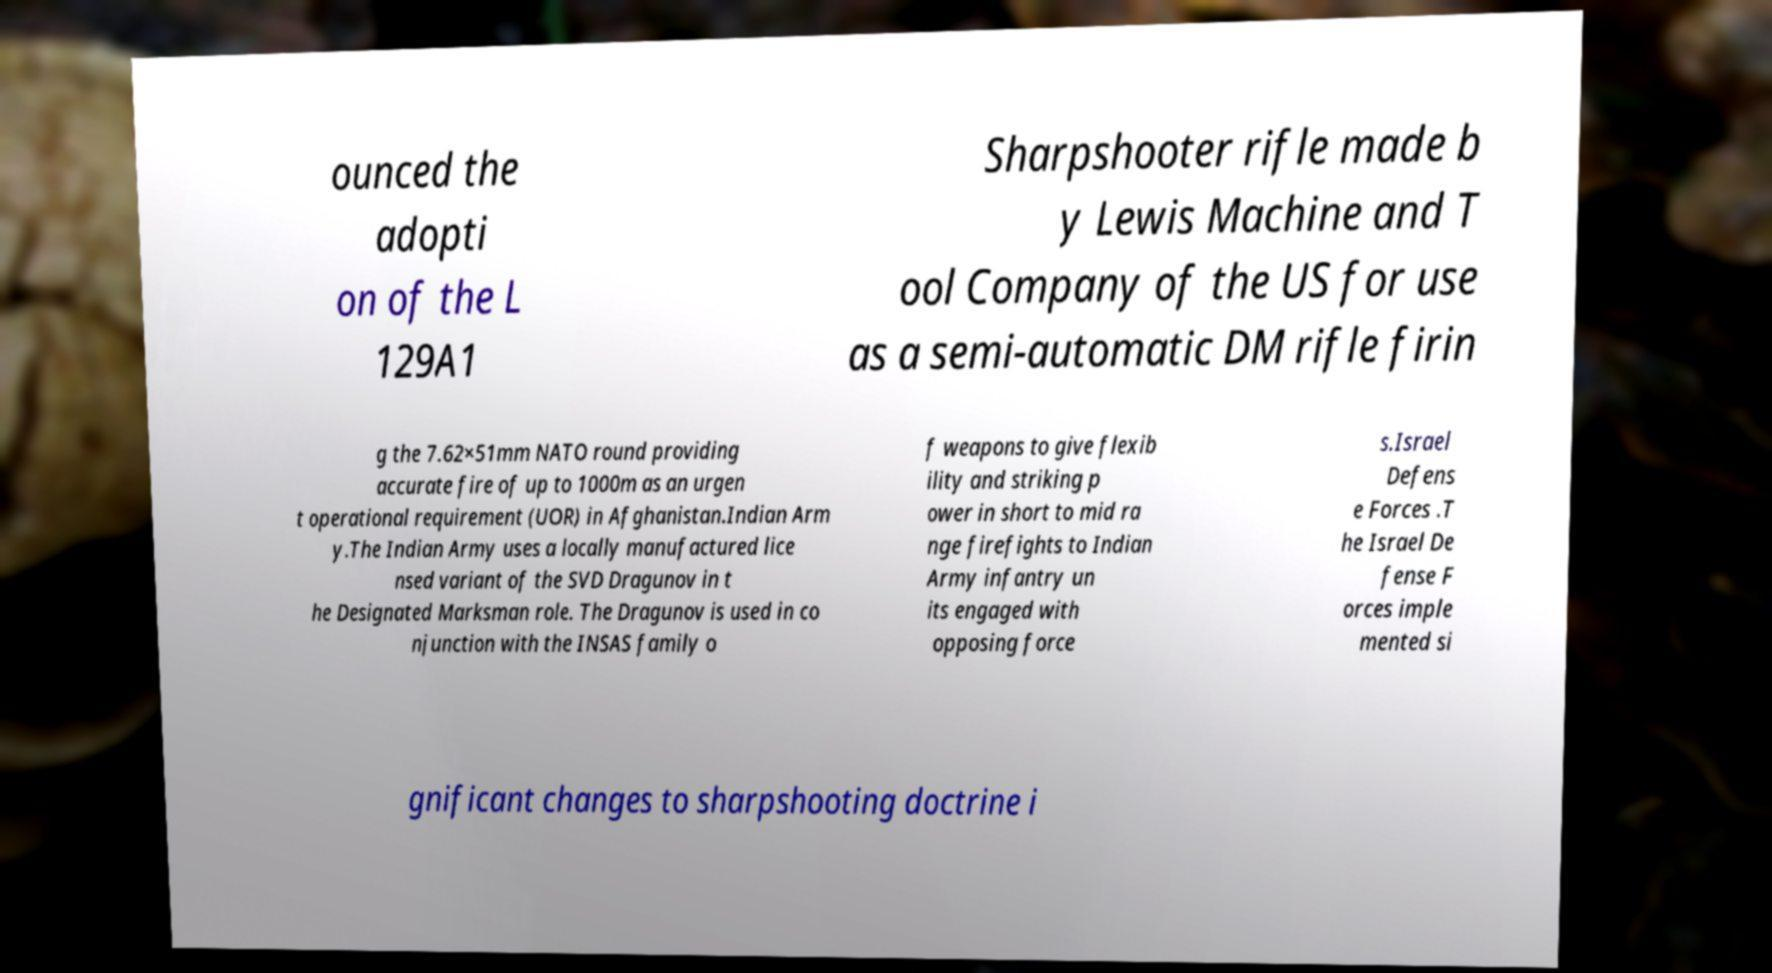Could you extract and type out the text from this image? ounced the adopti on of the L 129A1 Sharpshooter rifle made b y Lewis Machine and T ool Company of the US for use as a semi-automatic DM rifle firin g the 7.62×51mm NATO round providing accurate fire of up to 1000m as an urgen t operational requirement (UOR) in Afghanistan.Indian Arm y.The Indian Army uses a locally manufactured lice nsed variant of the SVD Dragunov in t he Designated Marksman role. The Dragunov is used in co njunction with the INSAS family o f weapons to give flexib ility and striking p ower in short to mid ra nge firefights to Indian Army infantry un its engaged with opposing force s.Israel Defens e Forces .T he Israel De fense F orces imple mented si gnificant changes to sharpshooting doctrine i 